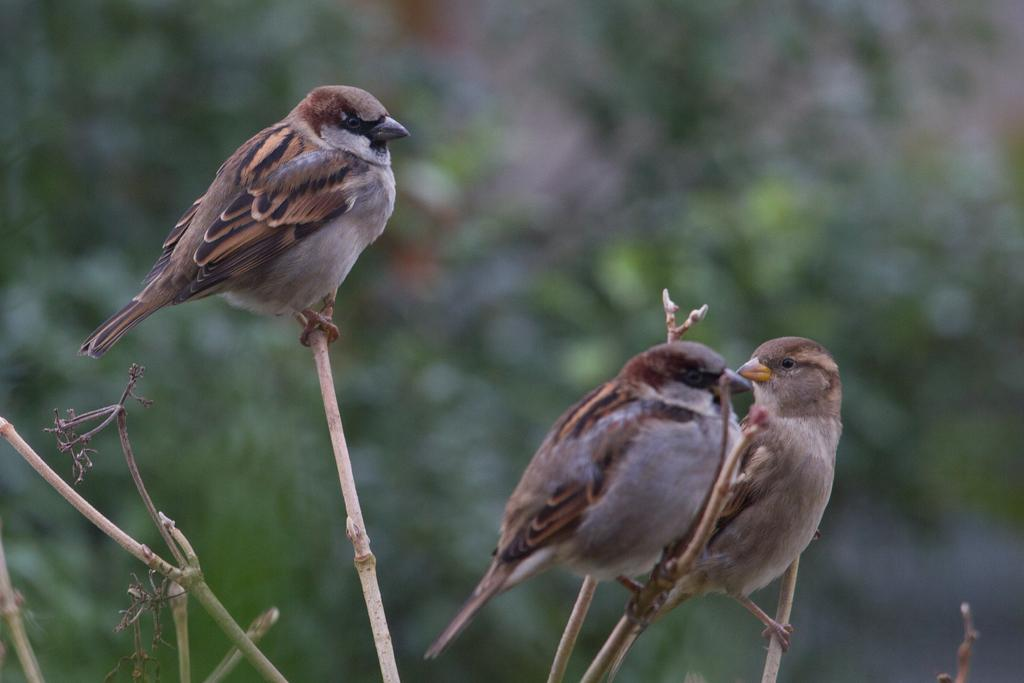What type of birds are in the foreground of the picture? There are sparrows in the foreground of the picture. What are the sparrows sitting on? The sparrows are sitting on stems. Can you describe the background of the image? The background of the image is blurred. What type of environment is visible in the background? There is greenery in the background of the image. How does the door in the image lead to the quicksand? There is no door or quicksand present in the image; it features sparrows sitting on stems with a blurred background of greenery. 